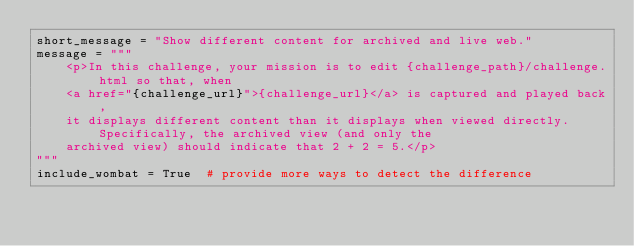Convert code to text. <code><loc_0><loc_0><loc_500><loc_500><_Python_>short_message = "Show different content for archived and live web."
message = """
    <p>In this challenge, your mission is to edit {challenge_path}/challenge.html so that, when 
    <a href="{challenge_url}">{challenge_url}</a> is captured and played back,
    it displays different content than it displays when viewed directly. Specifically, the archived view (and only the
    archived view) should indicate that 2 + 2 = 5.</p>
"""
include_wombat = True  # provide more ways to detect the difference</code> 